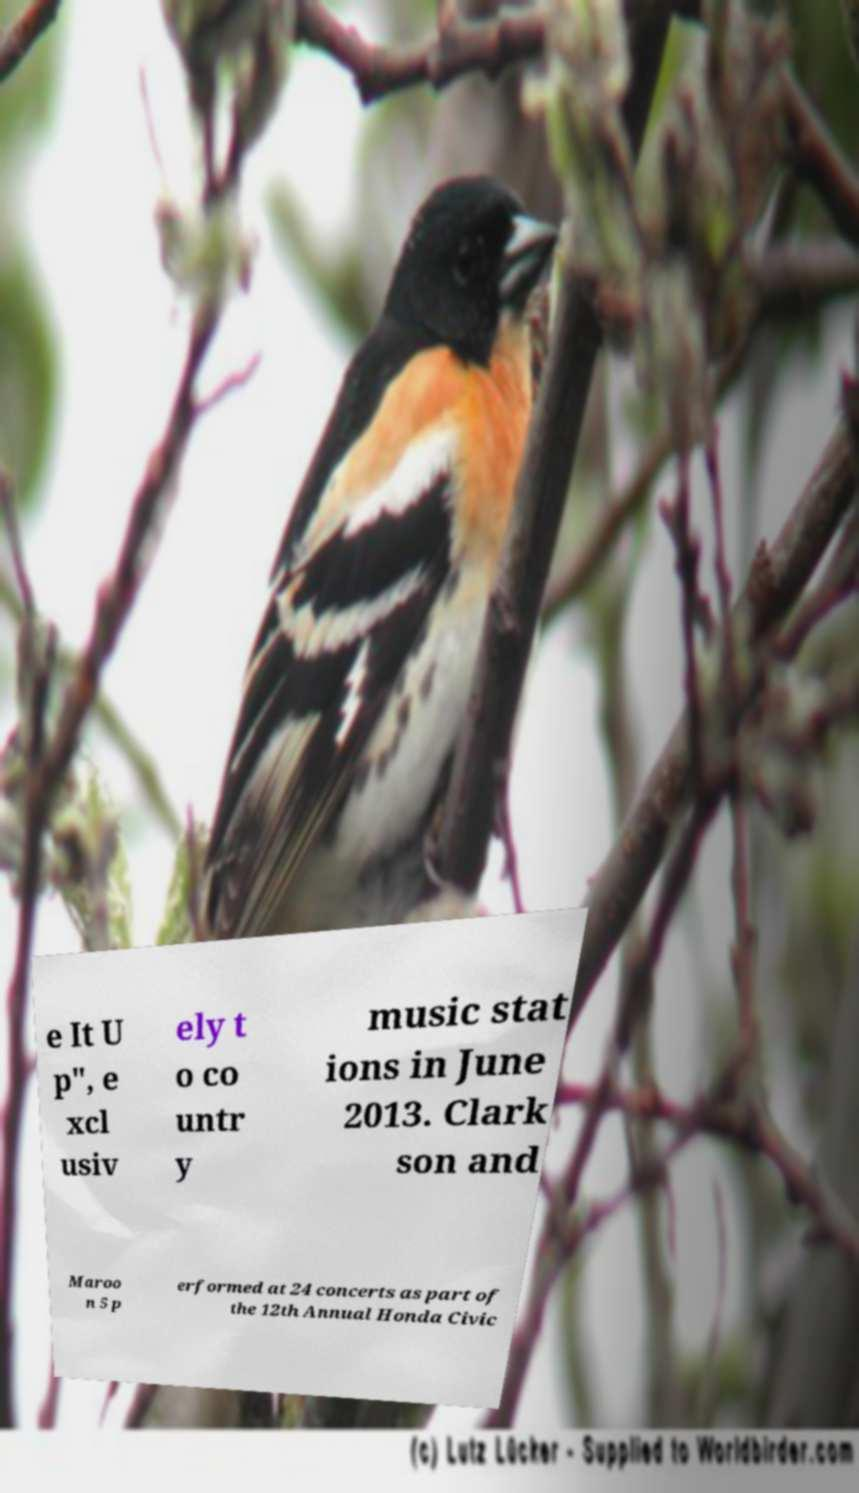There's text embedded in this image that I need extracted. Can you transcribe it verbatim? e It U p", e xcl usiv ely t o co untr y music stat ions in June 2013. Clark son and Maroo n 5 p erformed at 24 concerts as part of the 12th Annual Honda Civic 